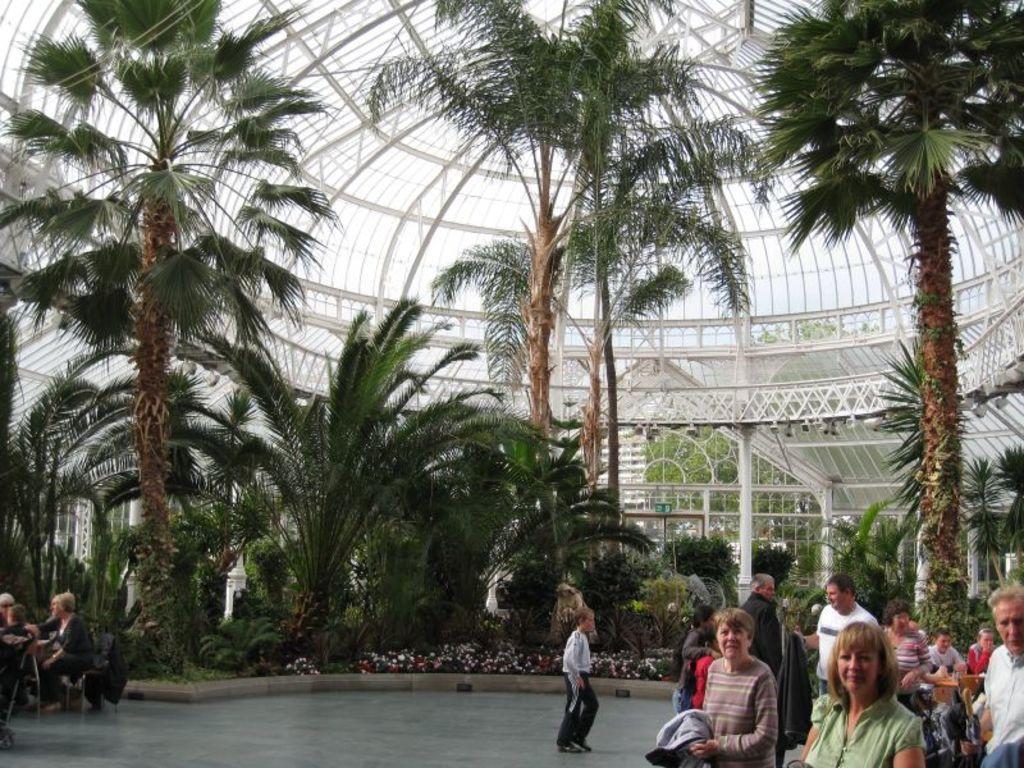Describe this image in one or two sentences. In this image, at the bottom there are two women. In the middle there is a boy, he is walking. On the left there are some people. On the right there are some people. In the background there are trees, roof, building, plants, floor. 